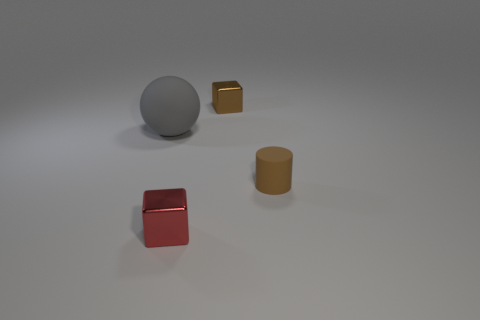What number of large purple cylinders are there?
Your answer should be compact. 0. Is there a green block made of the same material as the brown block?
Give a very brief answer. No. There is a metallic object behind the tiny rubber cylinder; does it have the same size as the matte object behind the small brown rubber thing?
Your response must be concise. No. There is a rubber thing that is to the right of the red cube; what size is it?
Ensure brevity in your answer.  Small. Are there any things of the same color as the cylinder?
Offer a very short reply. Yes. Are there any small things that are to the right of the shiny object in front of the brown metallic block?
Give a very brief answer. Yes. There is a red cube; does it have the same size as the matte object behind the brown cylinder?
Keep it short and to the point. No. There is a metallic object that is right of the object that is in front of the tiny cylinder; are there any brown matte objects in front of it?
Make the answer very short. Yes. There is a brown object to the right of the small brown metallic block; what is it made of?
Make the answer very short. Rubber. Is the size of the brown matte object the same as the red block?
Give a very brief answer. Yes. 